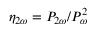Convert formula to latex. <formula><loc_0><loc_0><loc_500><loc_500>\eta _ { 2 \omega } = P _ { 2 \omega } / P _ { \omega } ^ { 2 }</formula> 